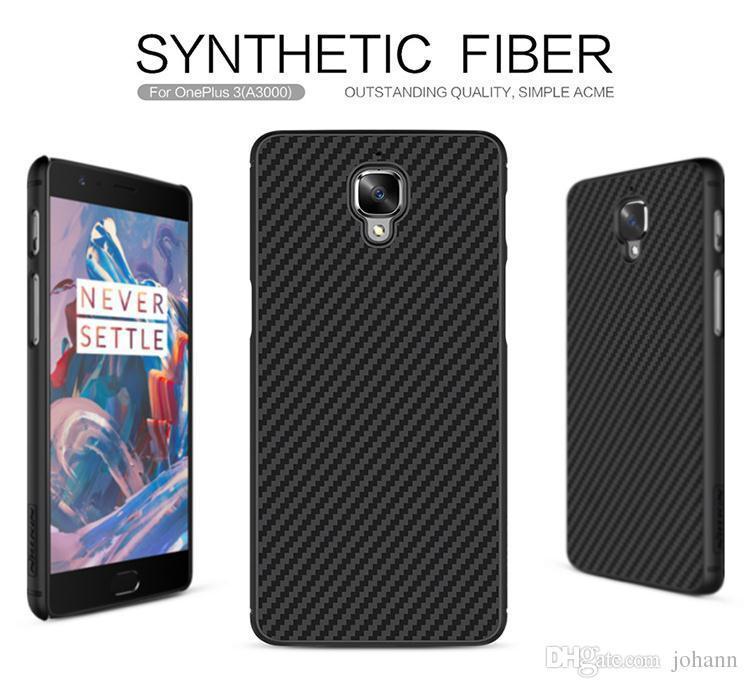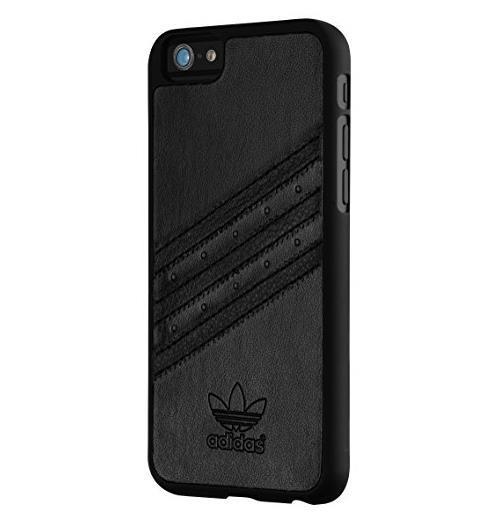The first image is the image on the left, the second image is the image on the right. Evaluate the accuracy of this statement regarding the images: "The left and right image contains the same number of phones with at least one backside of the phone showing.". Is it true? Answer yes or no. No. The first image is the image on the left, the second image is the image on the right. Considering the images on both sides, is "Each image contains exactly two phones, and the phones depicted are displayed upright but not overlapping." valid? Answer yes or no. No. 